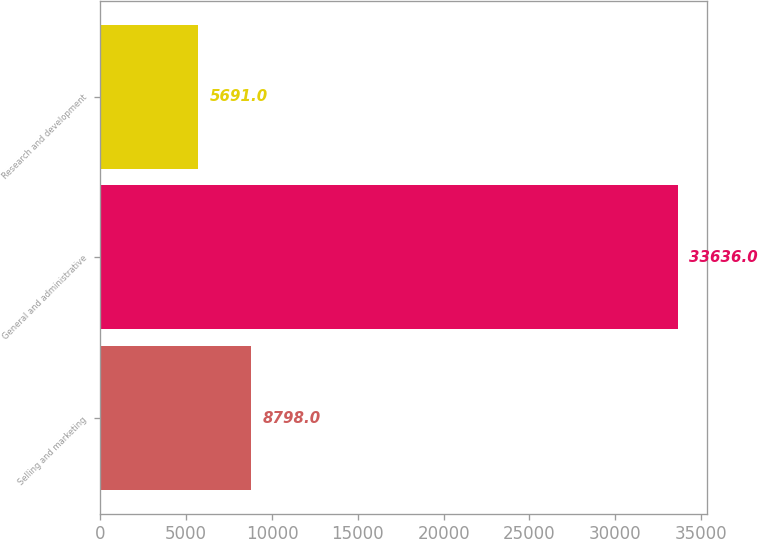<chart> <loc_0><loc_0><loc_500><loc_500><bar_chart><fcel>Selling and marketing<fcel>General and administrative<fcel>Research and development<nl><fcel>8798<fcel>33636<fcel>5691<nl></chart> 